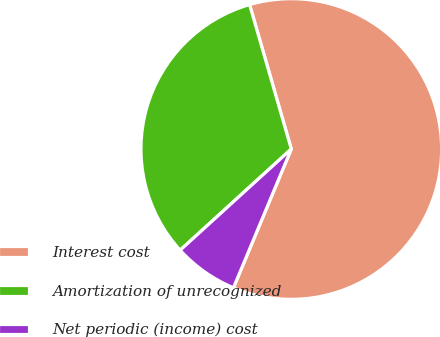Convert chart to OTSL. <chart><loc_0><loc_0><loc_500><loc_500><pie_chart><fcel>Interest cost<fcel>Amortization of unrecognized<fcel>Net periodic (income) cost<nl><fcel>60.76%<fcel>32.28%<fcel>6.96%<nl></chart> 